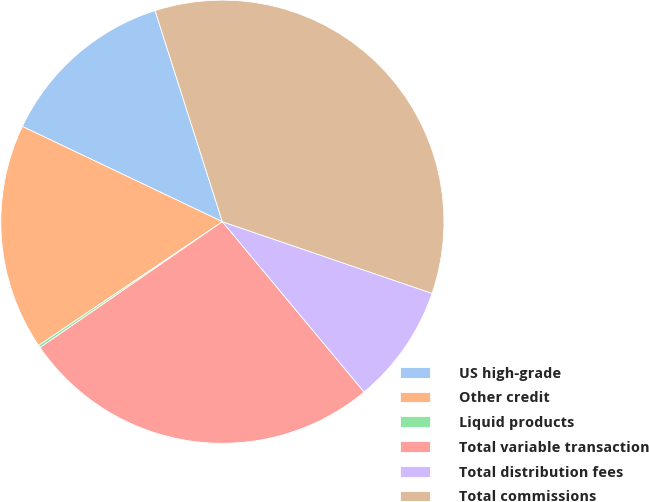Convert chart. <chart><loc_0><loc_0><loc_500><loc_500><pie_chart><fcel>US high-grade<fcel>Other credit<fcel>Liquid products<fcel>Total variable transaction<fcel>Total distribution fees<fcel>Total commissions<nl><fcel>13.01%<fcel>16.5%<fcel>0.19%<fcel>26.43%<fcel>8.71%<fcel>35.15%<nl></chart> 